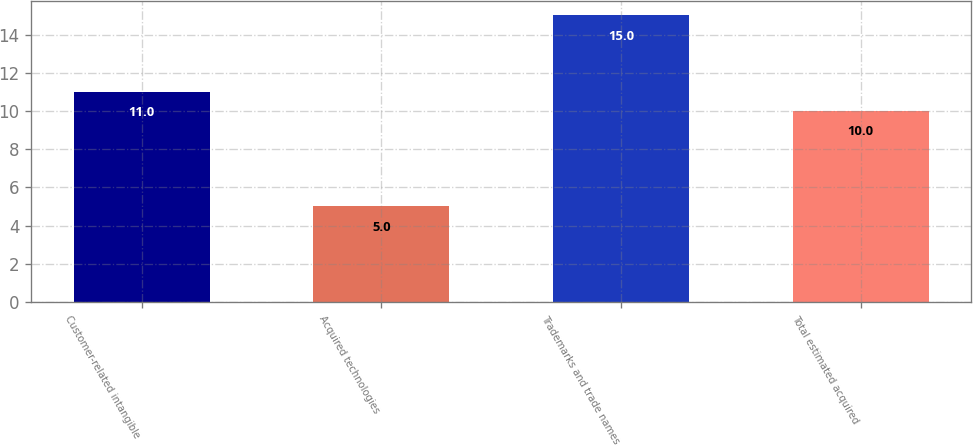Convert chart to OTSL. <chart><loc_0><loc_0><loc_500><loc_500><bar_chart><fcel>Customer-related intangible<fcel>Acquired technologies<fcel>Trademarks and trade names<fcel>Total estimated acquired<nl><fcel>11<fcel>5<fcel>15<fcel>10<nl></chart> 